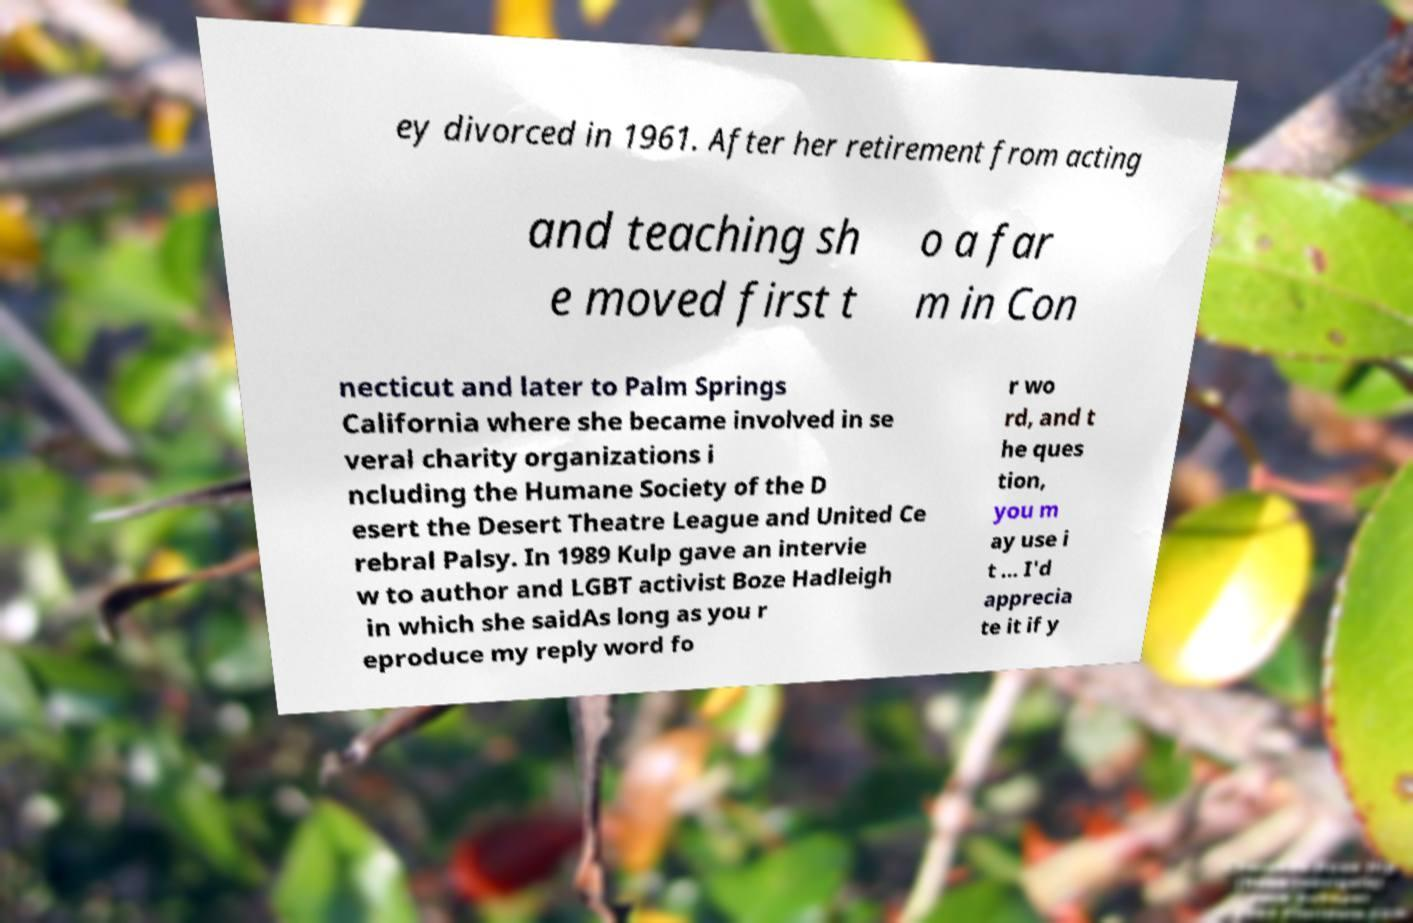I need the written content from this picture converted into text. Can you do that? ey divorced in 1961. After her retirement from acting and teaching sh e moved first t o a far m in Con necticut and later to Palm Springs California where she became involved in se veral charity organizations i ncluding the Humane Society of the D esert the Desert Theatre League and United Ce rebral Palsy. In 1989 Kulp gave an intervie w to author and LGBT activist Boze Hadleigh in which she saidAs long as you r eproduce my reply word fo r wo rd, and t he ques tion, you m ay use i t ... I'd apprecia te it if y 